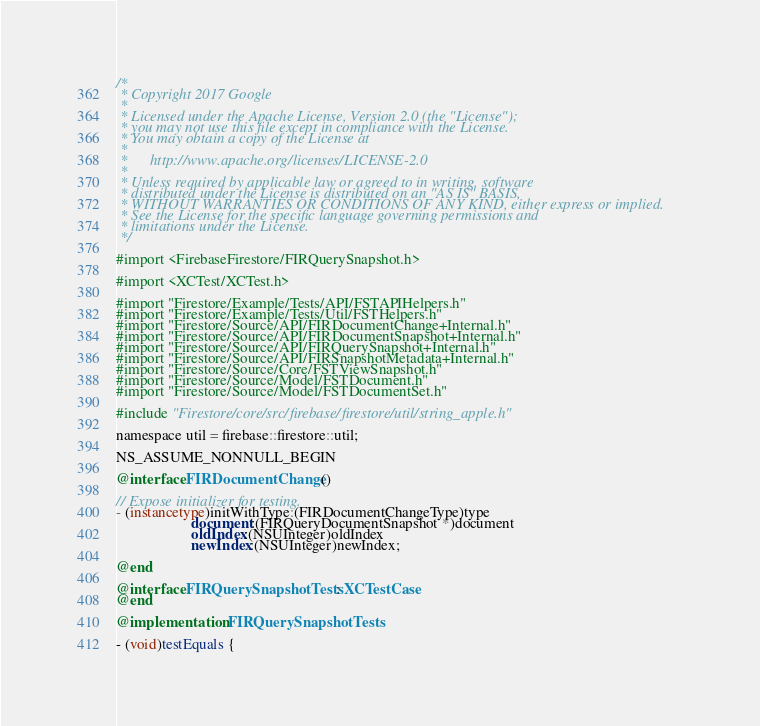<code> <loc_0><loc_0><loc_500><loc_500><_ObjectiveC_>/*
 * Copyright 2017 Google
 *
 * Licensed under the Apache License, Version 2.0 (the "License");
 * you may not use this file except in compliance with the License.
 * You may obtain a copy of the License at
 *
 *      http://www.apache.org/licenses/LICENSE-2.0
 *
 * Unless required by applicable law or agreed to in writing, software
 * distributed under the License is distributed on an "AS IS" BASIS,
 * WITHOUT WARRANTIES OR CONDITIONS OF ANY KIND, either express or implied.
 * See the License for the specific language governing permissions and
 * limitations under the License.
 */

#import <FirebaseFirestore/FIRQuerySnapshot.h>

#import <XCTest/XCTest.h>

#import "Firestore/Example/Tests/API/FSTAPIHelpers.h"
#import "Firestore/Example/Tests/Util/FSTHelpers.h"
#import "Firestore/Source/API/FIRDocumentChange+Internal.h"
#import "Firestore/Source/API/FIRDocumentSnapshot+Internal.h"
#import "Firestore/Source/API/FIRQuerySnapshot+Internal.h"
#import "Firestore/Source/API/FIRSnapshotMetadata+Internal.h"
#import "Firestore/Source/Core/FSTViewSnapshot.h"
#import "Firestore/Source/Model/FSTDocument.h"
#import "Firestore/Source/Model/FSTDocumentSet.h"

#include "Firestore/core/src/firebase/firestore/util/string_apple.h"

namespace util = firebase::firestore::util;

NS_ASSUME_NONNULL_BEGIN

@interface FIRDocumentChange ()

// Expose initializer for testing.
- (instancetype)initWithType:(FIRDocumentChangeType)type
                    document:(FIRQueryDocumentSnapshot *)document
                    oldIndex:(NSUInteger)oldIndex
                    newIndex:(NSUInteger)newIndex;

@end

@interface FIRQuerySnapshotTests : XCTestCase
@end

@implementation FIRQuerySnapshotTests

- (void)testEquals {</code> 